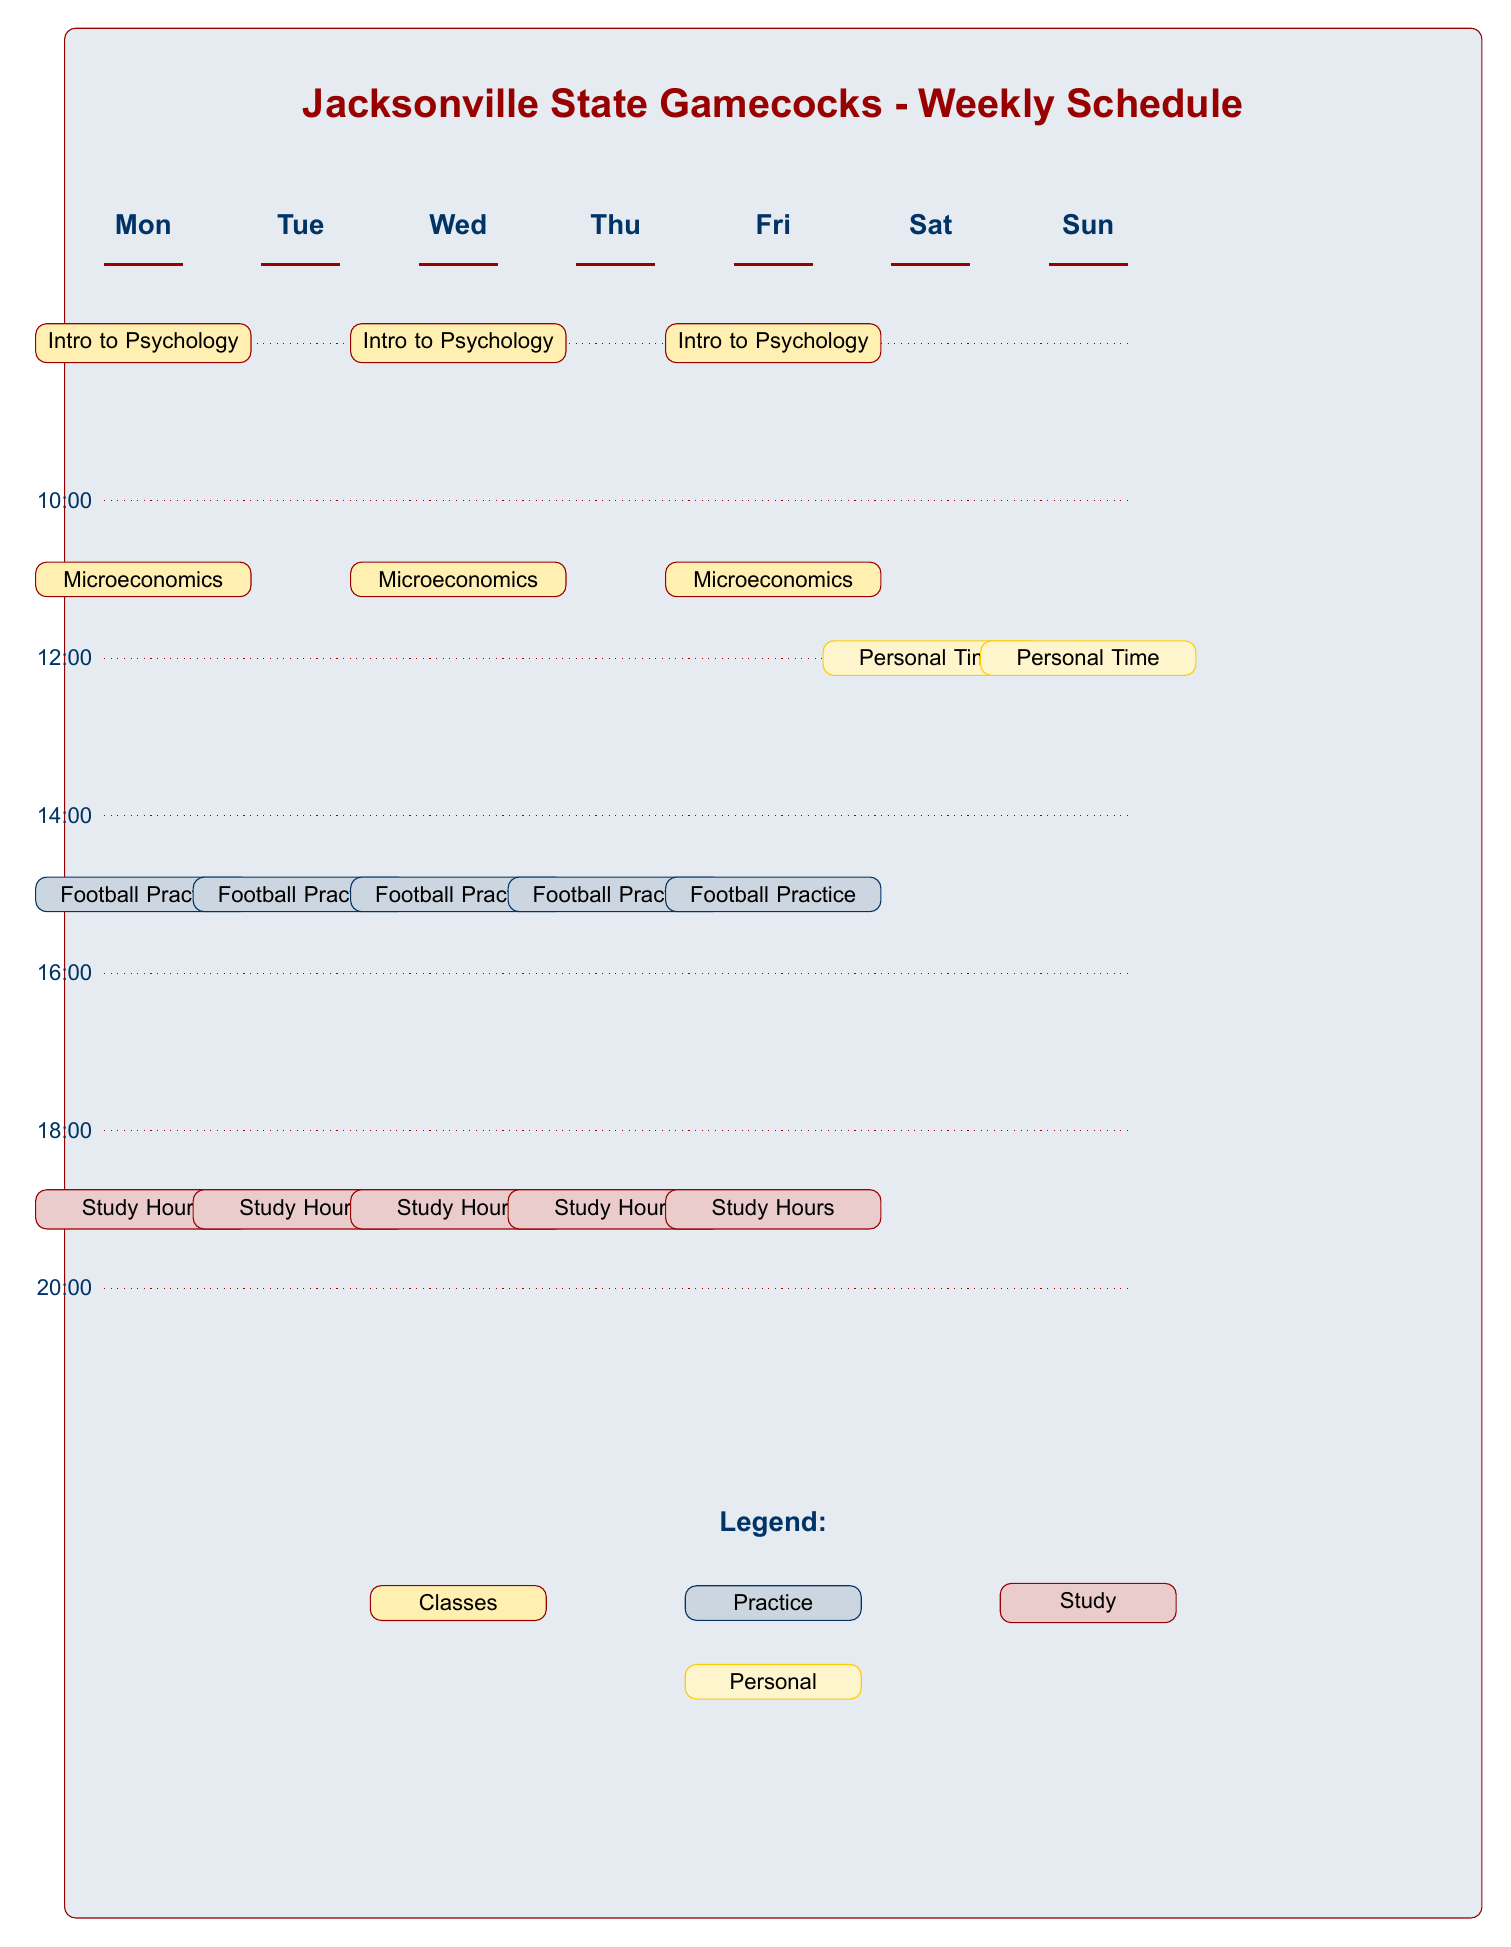What classes are scheduled on Wednesday at 8:00? The diagram shows the scheduled classes for each day and time. On Wednesday at 8:00, the class scheduled is "Intro to Psychology".
Answer: Intro to Psychology How many study hour blocks are there in total? Each day has one study hour block, and there are classes from Monday to Friday. Therefore, there are 5 total study hour blocks indicated in the diagram.
Answer: 5 Which two days have football practice sessions? By looking at the practice sessions in the diagram, we can see that they are scheduled on Monday and Wednesday.
Answer: Monday and Wednesday What time does personal time start on Saturday? The diagram indicates that personal time on Saturday is scheduled for 4:00.
Answer: 4:00 Which class is held on Friday? The diagram indicates that on Friday, the class scheduled is "Microeconomics".
Answer: Microeconomics How many days have the "Intro to Psychology" class scheduled? The diagram shows that "Intro to Psychology" is scheduled on Monday, Wednesday, and Friday, which adds up to three days.
Answer: 3 What is the color representing study hours in the legend? The legend indicates that the color representing study hours is a light red shade.
Answer: Light red Are there any personal time blocks on Sunday? By checking the diagram, personal time is not scheduled on Sunday; thus, there are no personal time blocks for that day.
Answer: No What is the total number of classes scheduled in the diagram? Looking at the classes on each day, there are a total of 6 classes scheduled in the diagram.
Answer: 6 